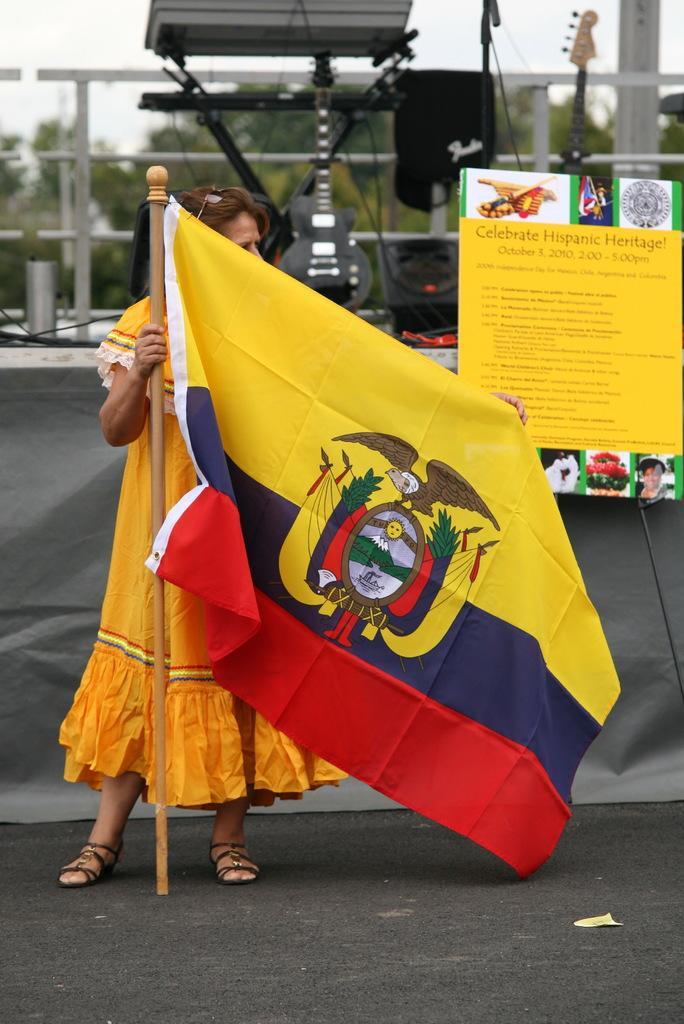Describe this image in one or two sentences. In the center of the image, we can see a lady holding flag and there is a board. In the background, we can see musical instruments. 